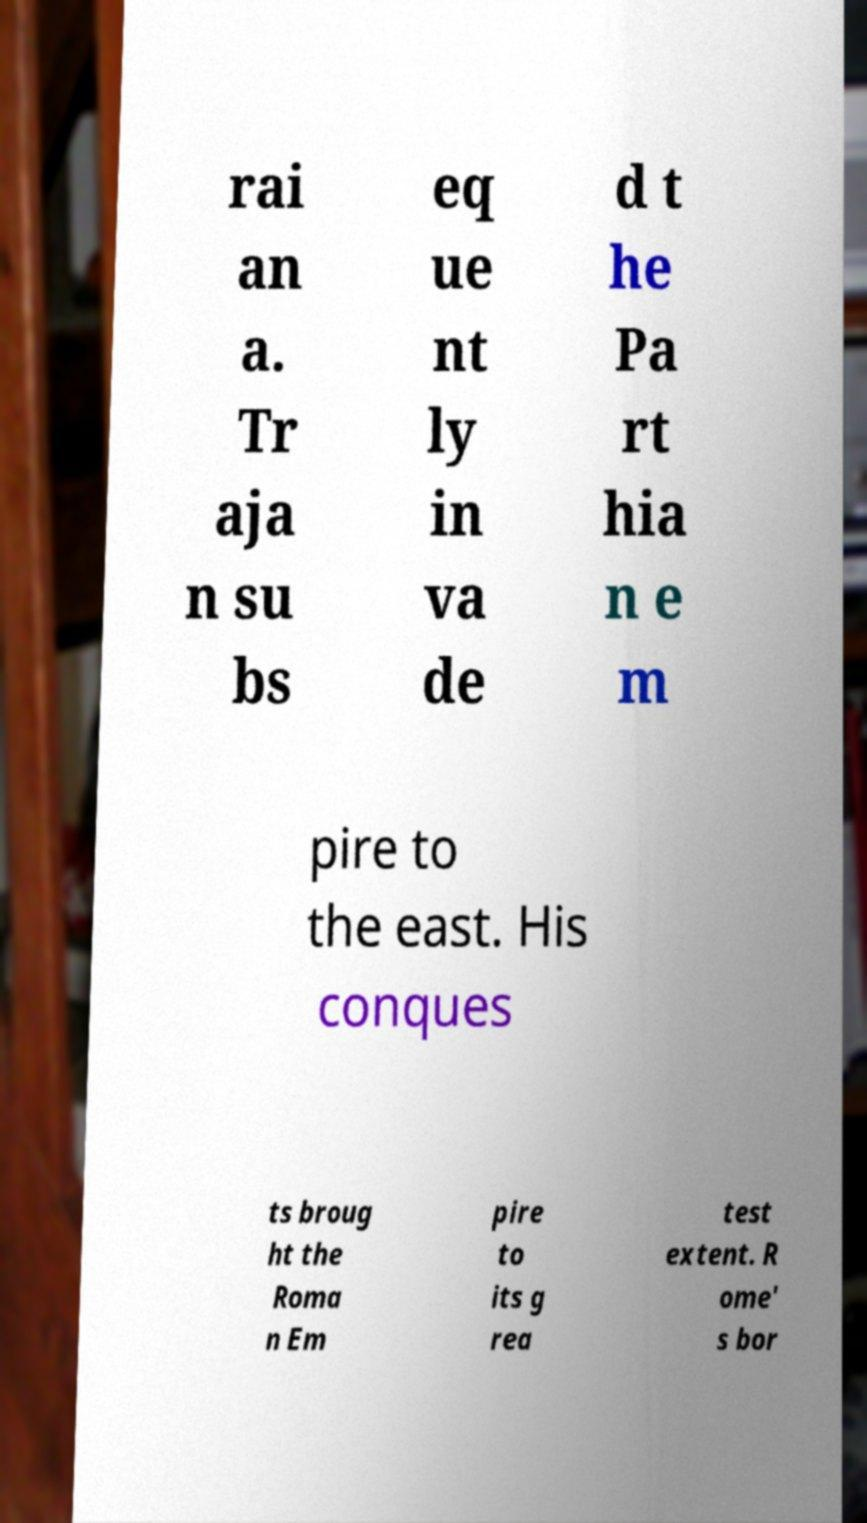Could you extract and type out the text from this image? rai an a. Tr aja n su bs eq ue nt ly in va de d t he Pa rt hia n e m pire to the east. His conques ts broug ht the Roma n Em pire to its g rea test extent. R ome' s bor 